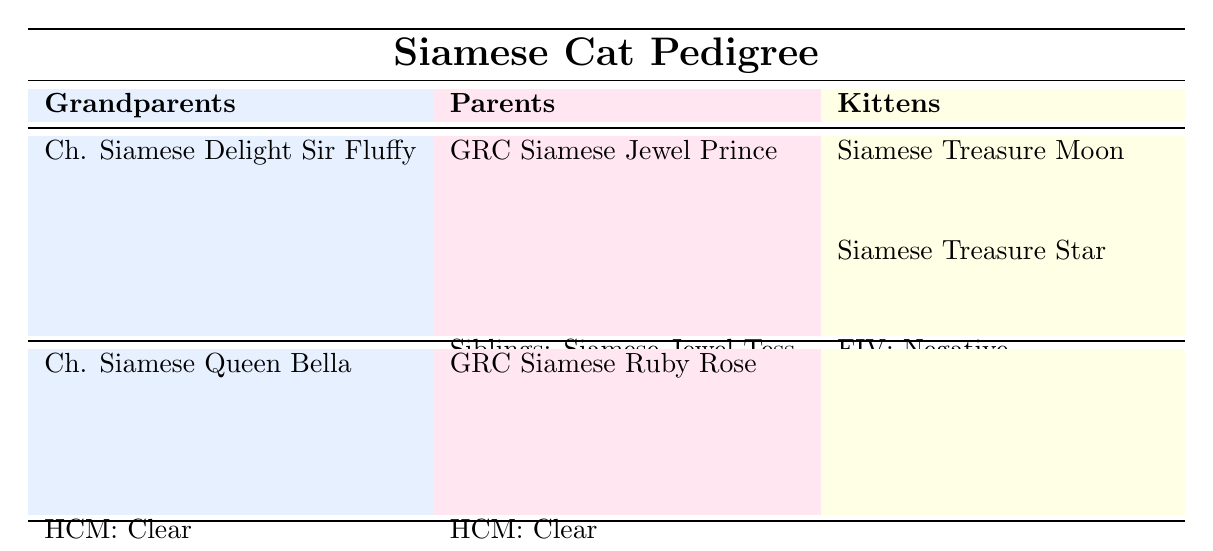What are the birth years of the grandparents? The birth years of the grandparents are listed directly in the first column of the table. Ch. Siamese Delight Sir Fluffy was born in 2015, and Ch. Siamese Queen Bella was born in 2016.
Answer: 2015 and 2016 Which color is GRC Siamese Ruby Rose? The color of GRC Siamese Ruby Rose is found in the second column under the Parents section. It indicates that the color is Lilac Point.
Answer: Lilac Point How many siblings does GRC Siamese Jewel Prince have? Looking at the entry for GRC Siamese Jewel Prince in the Parents section, it lists "Siamese Jewel Tess" and "Siamese Jewel Leo" as siblings. Thus, there are two siblings.
Answer: 2 Is HCM status for Siamese Treasure Moon clear? The health status of Siamese Treasure Moon is shown in the Kittens section, where HCM is stated as "Pending" not "Clear," so the answer is specifically related to whether it is clear.
Answer: No Which grandparent has the genetic trait "Pointed Pattern"? Both grandparents' genetic traits are provided in the table. Upon checking their entries, both Ch. Siamese Delight Sir Fluffy and Ch. Siamese Queen Bella have the genetic trait "Pointed Pattern." Therefore, the answer identifies both.
Answer: Both What is the total number of kittens listed? The total number of kittens can be calculated by looking at the Kittens section of the table, where there are two kittens listed: Siamese Treasure Moon and Siamese Treasure Star.
Answer: 2 Is GRC Siamese Ruby Rose older than GRC Siamese Jewel Prince? To answer this, we need to compare their birth years. GRC Siamese Ruby Rose was born in 2019, while GRC Siamese Jewel Prince was born in 2018. Since 2019 is greater than 2018, GRC Siamese Ruby Rose is younger.
Answer: No What is the average birth year of all Siamese cats listed in the table? To find the average birth year, we sum the birth years of all cats: 2015 (Ch. Siamese Delight Sir Fluffy) + 2016 (Ch. Siamese Queen Bella) + 2018 (GRC Siamese Jewel Prince) + 2019 (GRC Siamese Ruby Rose) + 2021 (Siamese Treasure Moon) + 2021 (Siamese Treasure Star) = 2015 + 2016 + 2018 + 2019 + 2021 + 2021 = 12110. Dividing by the total number of cats (6), the average birth year is 12110 / 6 = 2018.333, which rounds to 2018 when considering just the year.
Answer: 2018 